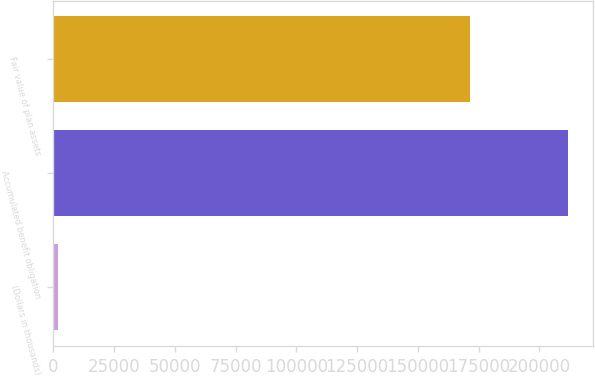<chart> <loc_0><loc_0><loc_500><loc_500><bar_chart><fcel>(Dollars in thousands)<fcel>Accumulated benefit obligation<fcel>Fair value of plan assets<nl><fcel>2016<fcel>211720<fcel>171506<nl></chart> 